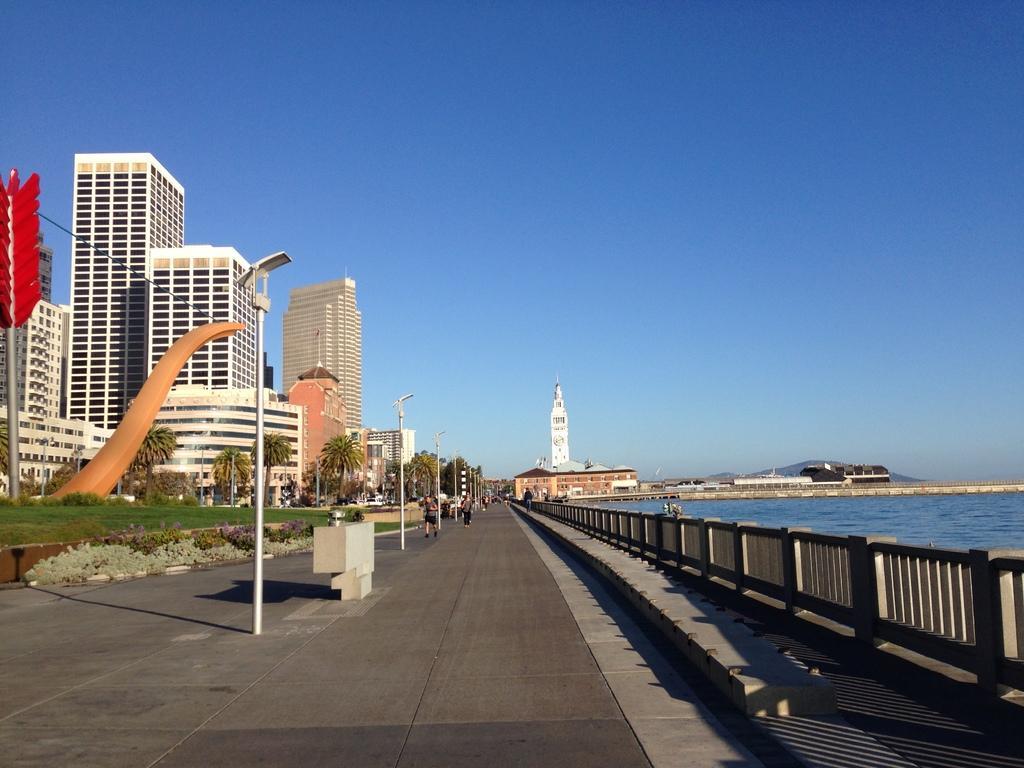In one or two sentences, can you explain what this image depicts? In this image, we can see so many buildings, tower, poles with lights, trees, grass, plants. At the bottom, we can see a platform, railing. Right side of the image, we can see a water. Here we can see few people. Top of the image, there is a sky. 